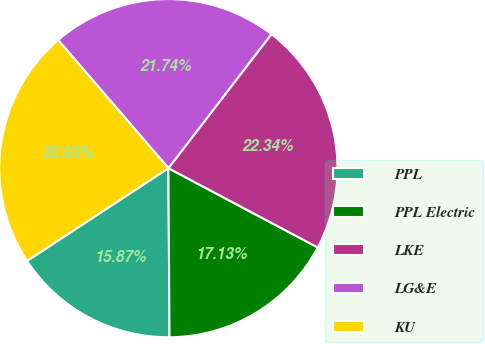Convert chart to OTSL. <chart><loc_0><loc_0><loc_500><loc_500><pie_chart><fcel>PPL<fcel>PPL Electric<fcel>LKE<fcel>LG&E<fcel>KU<nl><fcel>15.87%<fcel>17.13%<fcel>22.34%<fcel>21.74%<fcel>22.93%<nl></chart> 